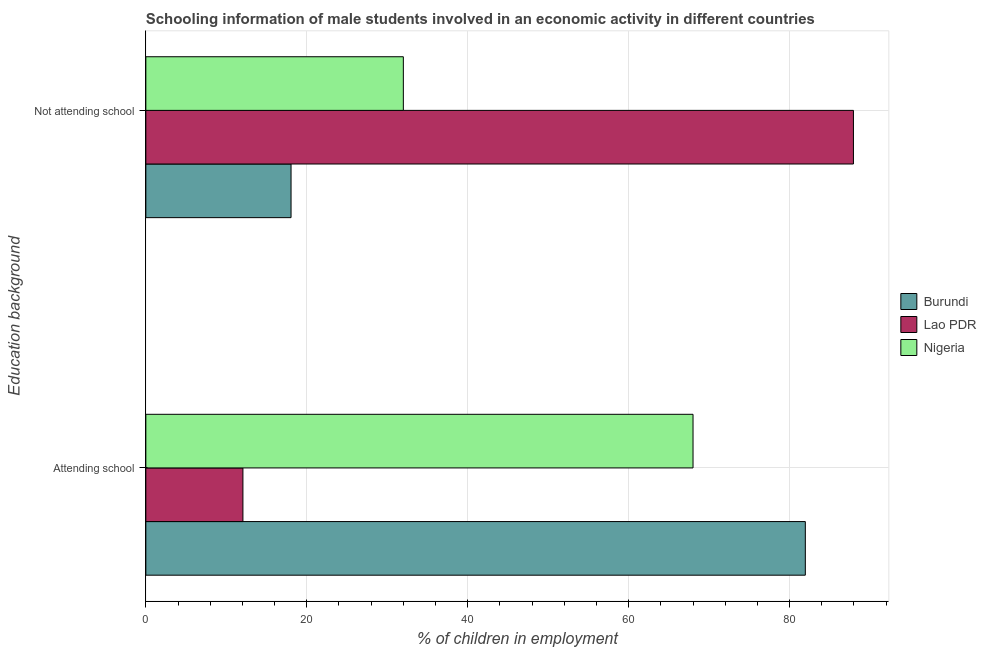How many different coloured bars are there?
Your response must be concise. 3. Are the number of bars per tick equal to the number of legend labels?
Provide a succinct answer. Yes. Are the number of bars on each tick of the Y-axis equal?
Offer a very short reply. Yes. How many bars are there on the 1st tick from the top?
Ensure brevity in your answer.  3. What is the label of the 2nd group of bars from the top?
Offer a very short reply. Attending school. What is the percentage of employed males who are attending school in Burundi?
Offer a very short reply. 81.96. Across all countries, what is the maximum percentage of employed males who are attending school?
Offer a terse response. 81.96. Across all countries, what is the minimum percentage of employed males who are attending school?
Your answer should be very brief. 12.07. In which country was the percentage of employed males who are not attending school maximum?
Your answer should be very brief. Lao PDR. In which country was the percentage of employed males who are attending school minimum?
Offer a very short reply. Lao PDR. What is the total percentage of employed males who are not attending school in the graph?
Offer a very short reply. 137.98. What is the difference between the percentage of employed males who are attending school in Lao PDR and that in Nigeria?
Keep it short and to the point. -55.93. What is the difference between the percentage of employed males who are attending school in Lao PDR and the percentage of employed males who are not attending school in Nigeria?
Your answer should be compact. -19.93. What is the average percentage of employed males who are attending school per country?
Keep it short and to the point. 54.01. What is the difference between the percentage of employed males who are not attending school and percentage of employed males who are attending school in Lao PDR?
Give a very brief answer. 75.87. What is the ratio of the percentage of employed males who are attending school in Nigeria to that in Lao PDR?
Make the answer very short. 5.64. Is the percentage of employed males who are attending school in Lao PDR less than that in Nigeria?
Provide a succinct answer. Yes. In how many countries, is the percentage of employed males who are not attending school greater than the average percentage of employed males who are not attending school taken over all countries?
Your response must be concise. 1. What does the 3rd bar from the top in Attending school represents?
Provide a short and direct response. Burundi. What does the 1st bar from the bottom in Not attending school represents?
Your answer should be compact. Burundi. What is the difference between two consecutive major ticks on the X-axis?
Provide a short and direct response. 20. Does the graph contain grids?
Your response must be concise. Yes. How many legend labels are there?
Offer a terse response. 3. How are the legend labels stacked?
Give a very brief answer. Vertical. What is the title of the graph?
Keep it short and to the point. Schooling information of male students involved in an economic activity in different countries. What is the label or title of the X-axis?
Provide a succinct answer. % of children in employment. What is the label or title of the Y-axis?
Your answer should be compact. Education background. What is the % of children in employment of Burundi in Attending school?
Your answer should be very brief. 81.96. What is the % of children in employment in Lao PDR in Attending school?
Your response must be concise. 12.07. What is the % of children in employment of Nigeria in Attending school?
Offer a terse response. 68. What is the % of children in employment in Burundi in Not attending school?
Provide a succinct answer. 18.04. What is the % of children in employment in Lao PDR in Not attending school?
Give a very brief answer. 87.93. Across all Education background, what is the maximum % of children in employment in Burundi?
Provide a succinct answer. 81.96. Across all Education background, what is the maximum % of children in employment in Lao PDR?
Provide a short and direct response. 87.93. Across all Education background, what is the minimum % of children in employment in Burundi?
Provide a short and direct response. 18.04. Across all Education background, what is the minimum % of children in employment of Lao PDR?
Your response must be concise. 12.07. Across all Education background, what is the minimum % of children in employment of Nigeria?
Keep it short and to the point. 32. What is the total % of children in employment in Lao PDR in the graph?
Offer a terse response. 100. What is the difference between the % of children in employment of Burundi in Attending school and that in Not attending school?
Provide a succinct answer. 63.91. What is the difference between the % of children in employment of Lao PDR in Attending school and that in Not attending school?
Give a very brief answer. -75.87. What is the difference between the % of children in employment of Nigeria in Attending school and that in Not attending school?
Your response must be concise. 36. What is the difference between the % of children in employment in Burundi in Attending school and the % of children in employment in Lao PDR in Not attending school?
Make the answer very short. -5.98. What is the difference between the % of children in employment in Burundi in Attending school and the % of children in employment in Nigeria in Not attending school?
Your answer should be very brief. 49.95. What is the difference between the % of children in employment in Lao PDR in Attending school and the % of children in employment in Nigeria in Not attending school?
Offer a terse response. -19.93. What is the difference between the % of children in employment in Burundi and % of children in employment in Lao PDR in Attending school?
Your answer should be compact. 69.89. What is the difference between the % of children in employment of Burundi and % of children in employment of Nigeria in Attending school?
Your answer should be very brief. 13.96. What is the difference between the % of children in employment of Lao PDR and % of children in employment of Nigeria in Attending school?
Your answer should be very brief. -55.93. What is the difference between the % of children in employment of Burundi and % of children in employment of Lao PDR in Not attending school?
Offer a terse response. -69.89. What is the difference between the % of children in employment in Burundi and % of children in employment in Nigeria in Not attending school?
Make the answer very short. -13.96. What is the difference between the % of children in employment of Lao PDR and % of children in employment of Nigeria in Not attending school?
Your response must be concise. 55.93. What is the ratio of the % of children in employment in Burundi in Attending school to that in Not attending school?
Keep it short and to the point. 4.54. What is the ratio of the % of children in employment in Lao PDR in Attending school to that in Not attending school?
Provide a short and direct response. 0.14. What is the ratio of the % of children in employment of Nigeria in Attending school to that in Not attending school?
Your answer should be very brief. 2.12. What is the difference between the highest and the second highest % of children in employment of Burundi?
Your answer should be very brief. 63.91. What is the difference between the highest and the second highest % of children in employment of Lao PDR?
Provide a succinct answer. 75.87. What is the difference between the highest and the second highest % of children in employment in Nigeria?
Ensure brevity in your answer.  36. What is the difference between the highest and the lowest % of children in employment in Burundi?
Make the answer very short. 63.91. What is the difference between the highest and the lowest % of children in employment of Lao PDR?
Give a very brief answer. 75.87. 